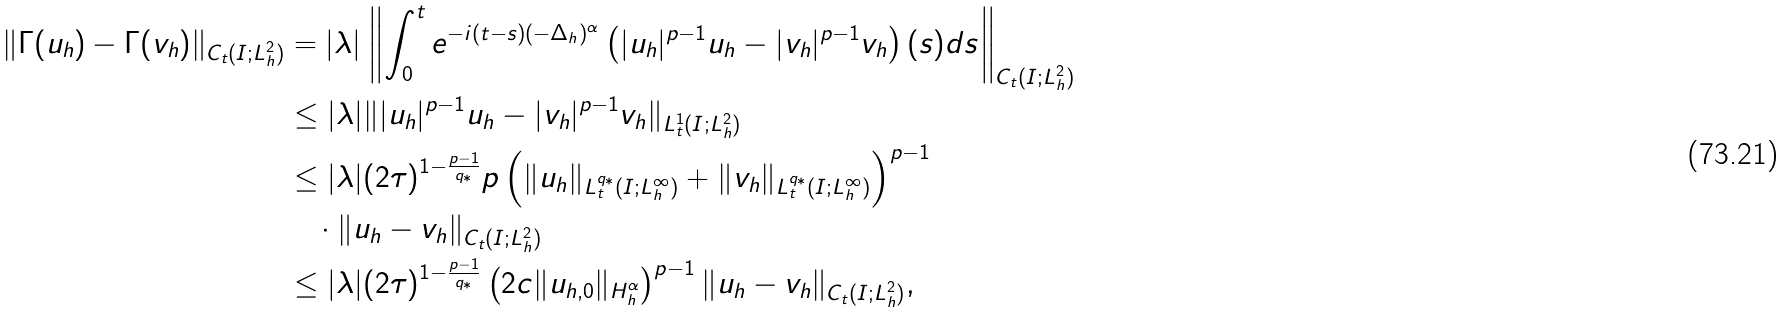<formula> <loc_0><loc_0><loc_500><loc_500>\| \Gamma ( u _ { h } ) - \Gamma ( v _ { h } ) \| _ { C _ { t } ( I ; L _ { h } ^ { 2 } ) } & = | \lambda | \left \| \int _ { 0 } ^ { t } e ^ { - i ( t - s ) ( - \Delta _ { h } ) ^ { \alpha } } \left ( | u _ { h } | ^ { p - 1 } u _ { h } - | v _ { h } | ^ { p - 1 } v _ { h } \right ) ( s ) d s \right \| _ { C _ { t } ( I ; L _ { h } ^ { 2 } ) } \\ & \leq | \lambda | \| | u _ { h } | ^ { p - 1 } u _ { h } - | v _ { h } | ^ { p - 1 } v _ { h } \| _ { L _ { t } ^ { 1 } ( I ; L _ { h } ^ { 2 } ) } \\ & \leq | \lambda | ( 2 \tau ) ^ { 1 - \frac { p - 1 } { q _ { * } } } p \left ( \| u _ { h } \| _ { L _ { t } ^ { q _ { * } } ( I ; L _ { h } ^ { \infty } ) } + \| v _ { h } \| _ { L _ { t } ^ { q _ { * } } ( I ; L _ { h } ^ { \infty } ) } \right ) ^ { p - 1 } \\ & \quad \cdot \| u _ { h } - v _ { h } \| _ { C _ { t } ( I ; L _ { h } ^ { 2 } ) } \\ & \leq | \lambda | ( 2 \tau ) ^ { 1 - \frac { p - 1 } { q _ { * } } } \left ( 2 c \| u _ { h , 0 } \| _ { H _ { h } ^ { \alpha } } \right ) ^ { p - 1 } \| u _ { h } - v _ { h } \| _ { C _ { t } ( I ; L _ { h } ^ { 2 } ) } ,</formula> 